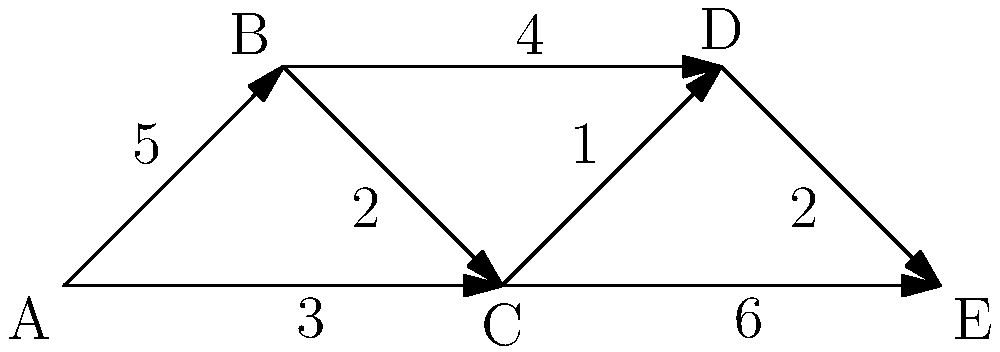Given the network topology above, where each node represents a firewall and the edges represent secure communication channels with their associated latency (in milliseconds), what is the shortest path for a data packet to travel from node A to node E? Provide the path and its total latency. To find the shortest path from node A to node E, we'll use Dijkstra's algorithm:

1. Initialize:
   - Distance to A: 0
   - Distance to all other nodes: infinity
   - Previous node for all: undefined
   - Unvisited set: {A, B, C, D, E}

2. Start from node A:
   - Update distances:
     B: min(∞, 0 + 5) = 5
     C: min(∞, 0 + 3) = 3
   - Mark A as visited
   - Unvisited set: {B, C, D, E}

3. Select node C (lowest distance):
   - Update distances:
     D: min(∞, 3 + 1) = 4
     E: min(∞, 3 + 6) = 9
   - Mark C as visited
   - Unvisited set: {B, D, E}

4. Select node D (lowest distance):
   - Update distances:
     E: min(9, 4 + 2) = 6
   - Mark D as visited
   - Unvisited set: {B, E}

5. Select node B (lowest distance):
   - No updates needed
   - Mark B as visited
   - Unvisited set: {E}

6. Select node E (only remaining):
   - Algorithm complete

The shortest path is A → C → D → E with a total latency of 6 ms.
Answer: A → C → D → E, 6 ms 